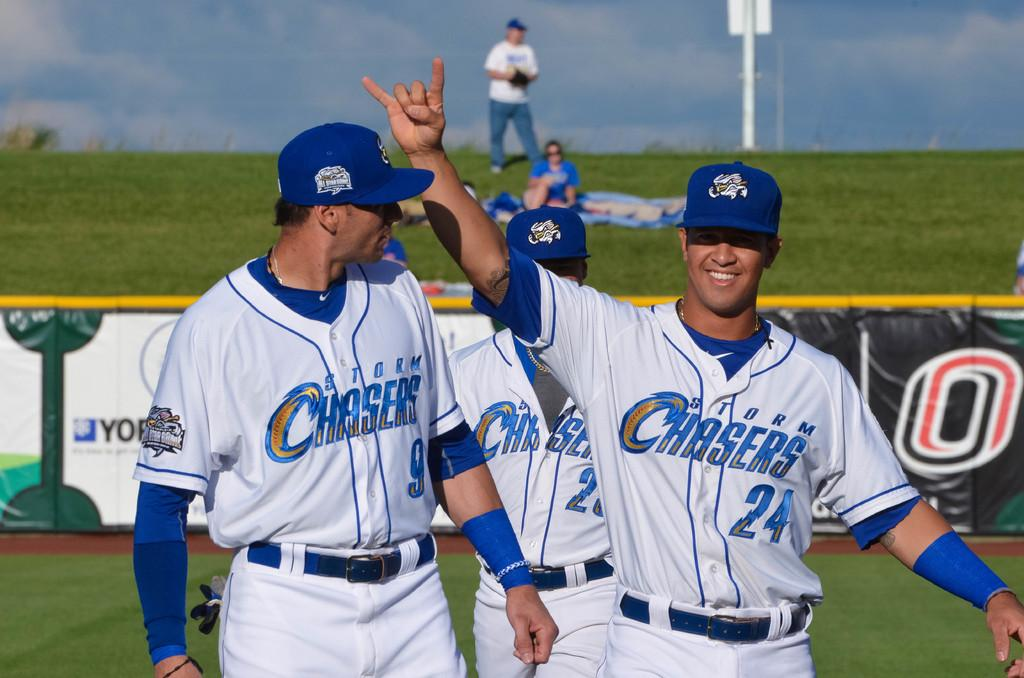Provide a one-sentence caption for the provided image. A man in a Storm Chasers uniform holds his hand up in the air. 